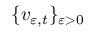<formula> <loc_0><loc_0><loc_500><loc_500>\{ v _ { \varepsilon , t } \} _ { \varepsilon > 0 }</formula> 